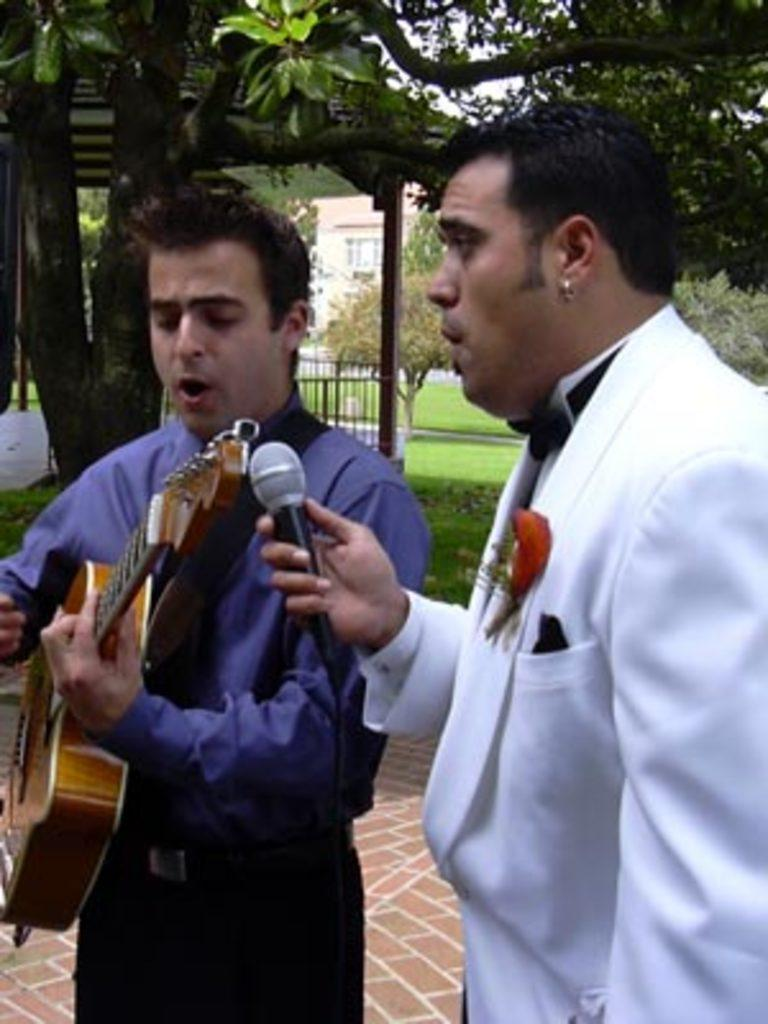How many people are in the image? There are two men in the image. What are the men holding in the image? The men are holding a microphone and a guitar. What can be seen in the background of the image? There are trees visible in the background of the image. What type of bucket is being used to defuse the bomb in the image? There is no bucket or bomb present in the image; it features two men holding a microphone and a guitar. 